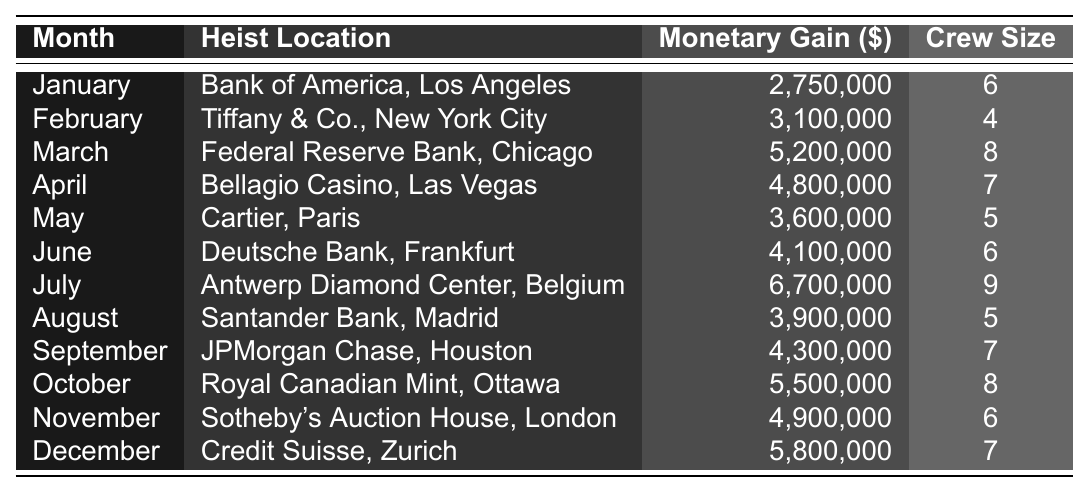What was the highest monetary gain from a heist in the year? The highest monetary gain listed in the table is 6,700,000 from the heist at the Antwerp Diamond Center in July.
Answer: 6,700,000 Which month had the least crew size involved in a heist? The least crew size involved in a heist is 4, which occurred in February at Tiffany & Co.
Answer: February What is the total monetary gain from heists conducted in the first half of the year? Summing the monetary gains from January to June: 2,750,000 + 3,100,000 + 5,200,000 + 4,800,000 + 3,600,000 + 4,100,000 = 23,550,000.
Answer: 23,550,000 Did any heist exceed a monetary gain of 5 million? Yes, the heists in March, July, October, and December all exceeded 5 million in monetary gain.
Answer: Yes How many crew members participated in the heist at Deutsche Bank? The crew size for the heist at Deutsche Bank in June is listed in the table as 6.
Answer: 6 What was the average monetary gain from heists in the second half of the year? The monetary gains for July to December are: 6,700,000, 3,900,000, 4,300,000, 5,500,000, 4,900,000, and 5,800,000. Summing these gives 31,100,000. Dividing by 6 gives an average of 5,183,333.33.
Answer: 5,183,333.33 Which month had a heist with more than 4 crew members but less than 5 million in gains? The months of May and August had crew sizes greater than 4 with monetary gains of 3,600,000 and 3,900,000, respectively, which are both under 5 million.
Answer: May, August How much more was gained from the heist at Bellagio Casino compared to the heist at Cartier? The gain from Bellagio is 4,800,000 and from Cartier is 3,600,000. The difference is 4,800,000 - 3,600,000 = 1,200,000.
Answer: 1,200,000 Was the heist in November more profitable than the one in January? Yes, the heist in November had a gain of 4,900,000, which is greater than the 2,750,000 gained in January.
Answer: Yes How many heists took place in the month of October and what was the monetary gain? There is one heist listed for October, which took place at the Royal Canadian Mint with a monetary gain of 5,500,000.
Answer: 1 heist, 5,500,000 